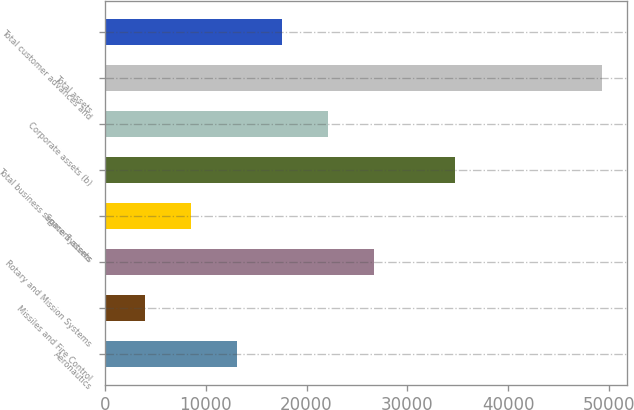Convert chart. <chart><loc_0><loc_0><loc_500><loc_500><bar_chart><fcel>Aeronautics<fcel>Missiles and Fire Control<fcel>Rotary and Mission Systems<fcel>Space Systems<fcel>Total business segment assets<fcel>Corporate assets (b)<fcel>Total assets<fcel>Total customer advances and<nl><fcel>13082.4<fcel>4027<fcel>26665.5<fcel>8554.7<fcel>34693<fcel>22137.8<fcel>49304<fcel>17610.1<nl></chart> 